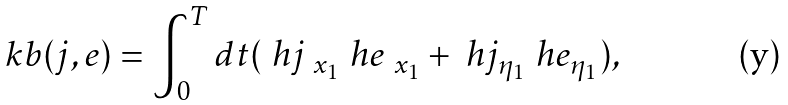<formula> <loc_0><loc_0><loc_500><loc_500>\ k b ( j , e ) = \int ^ { T } _ { 0 } d t ( \ h { j } _ { \ x _ { 1 } } \ h { e } _ { \ x _ { 1 } } + \ h { j } _ { \eta _ { 1 } } \ h { e } _ { \eta _ { 1 } } ) ,</formula> 